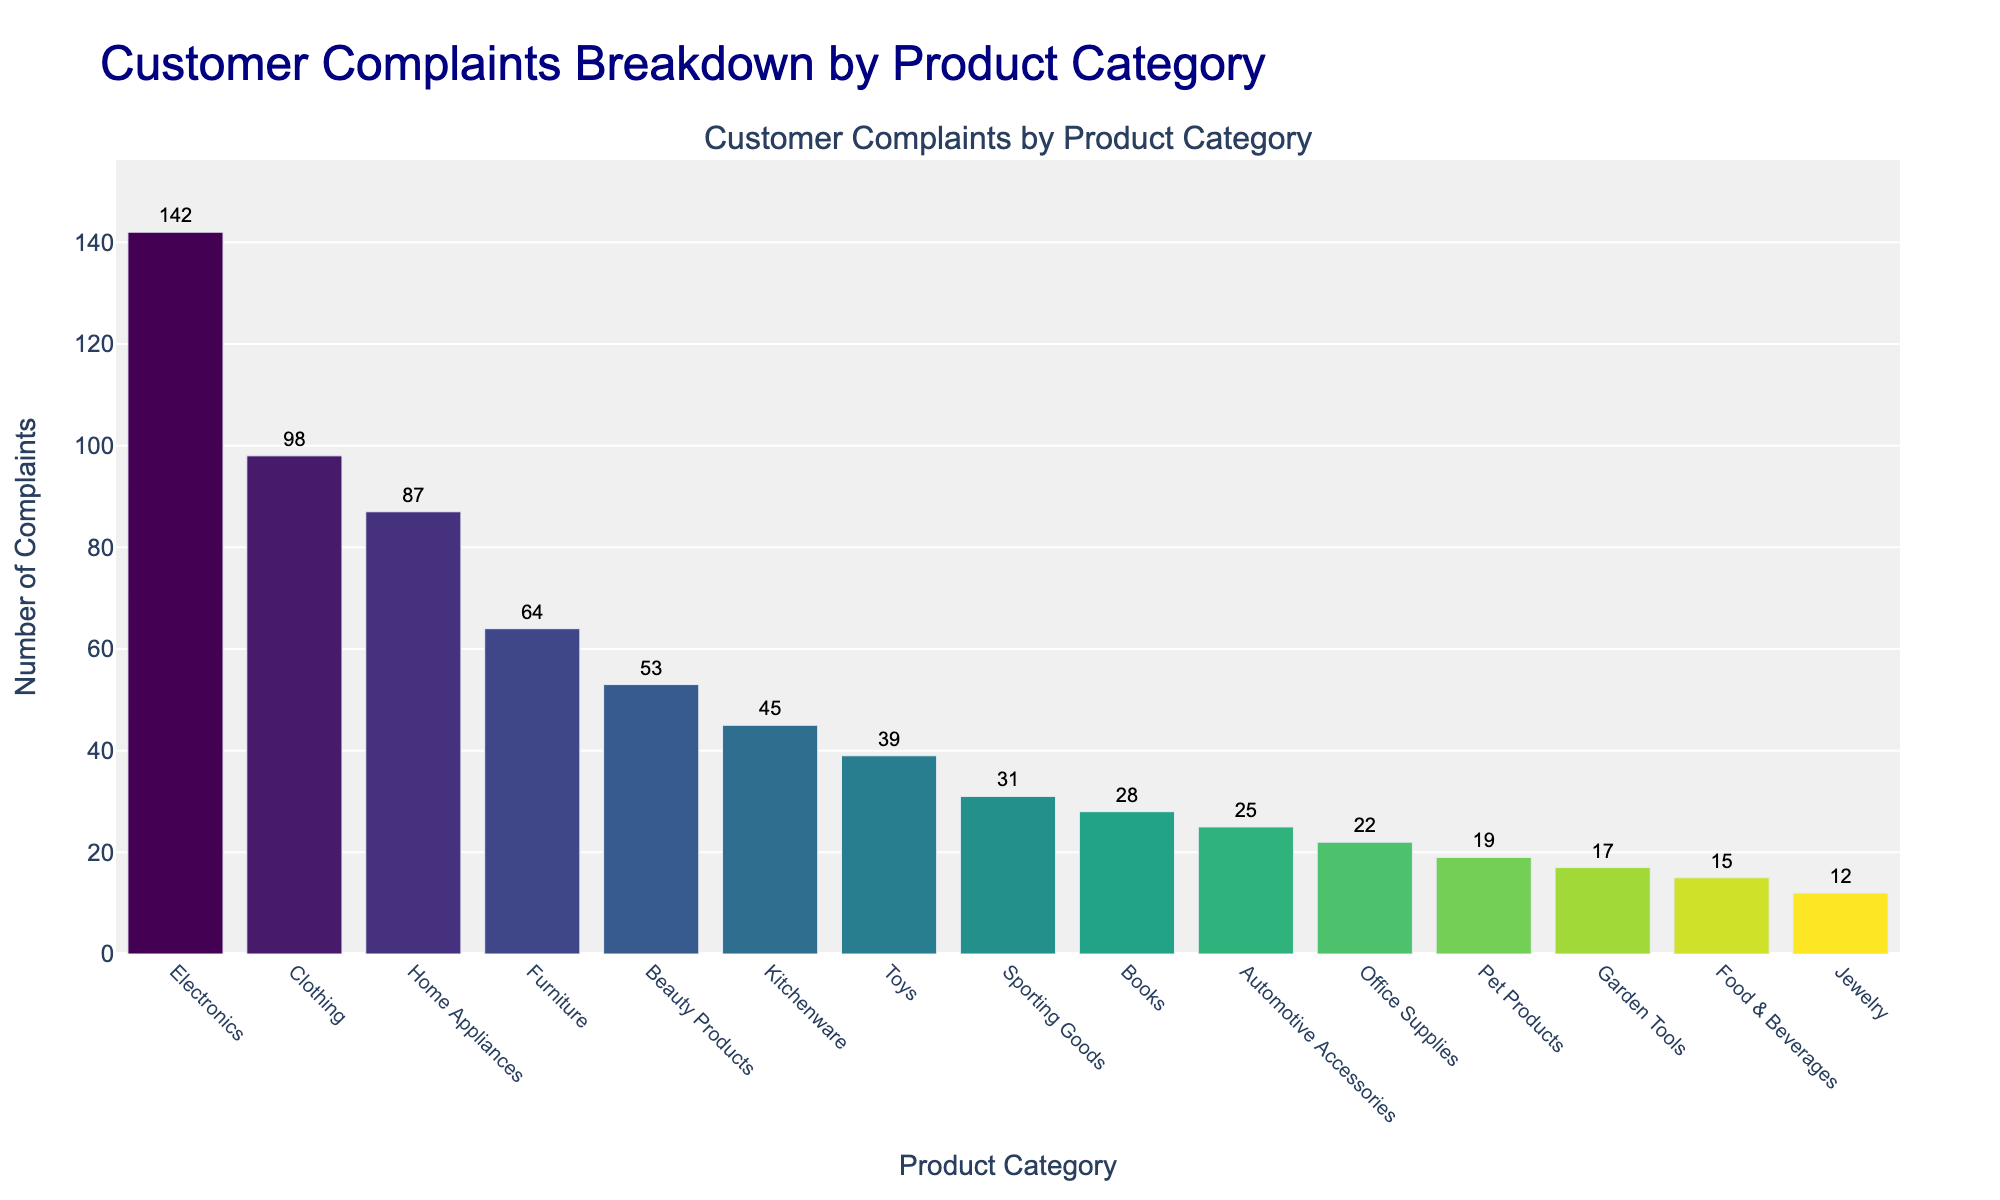Which product category received the highest number of complaints? The height of the bar for Electronics is the tallest among all categories on the bar chart.
Answer: Electronics What is the total number of complaints for Electronics and Clothing combined? The number of complaints for Electronics is 142, and for Clothing is 98. Summing them gives 142 + 98 = 240.
Answer: 240 Which product category received fewer complaints, Toys or Garden Tools? Comparing the heights of the bars, the bar for Garden Tools is shorter than that for Toys. Toys have 39 complaints, while Garden Tools have 17 complaints.
Answer: Garden Tools Are there more complaints in the Beauty Products category or the Kitchenware category? The height of the bar for Beauty Products is higher than for Kitchenware. Beauty Products have 53 complaints, while Kitchenware has 45 complaints.
Answer: Beauty Products What is the difference in the number of complaints between Home Appliances and Furniture? The number of complaints for Home Appliances is 87, and for Furniture is 64. The difference is 87 - 64 = 23.
Answer: 23 Which product category has the lowest number of complaints? The shortest bar on the chart corresponds to Jewelry.
Answer: Jewelry What is the combined number of complaints for the categories with fewer than 20 complaints each? The categories with fewer than 20 complaints are Pet Products (19), Garden Tools (17), Food & Beverages (15), and Jewelry (12). Summing these, we get 19 + 17 + 15 + 12 = 63.
Answer: 63 How many categories have more than 50 complaints? Counting the bars taller than the level representing 50 complaints, there are four categories: Electronics, Clothing, Home Appliances, and Beauty Products.
Answer: 4 What is the median value of the complaints across all product categories? Sorting the values: [12, 15, 17, 19, 22, 25, 28, 31, 39, 45, 53, 64, 87, 98, 142]; the median value (middle value) in the sorted list of 15 numbers is the 8th number, which is 31.
Answer: 31 